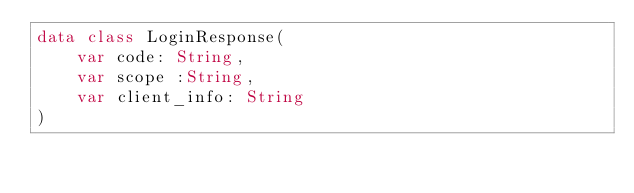<code> <loc_0><loc_0><loc_500><loc_500><_Kotlin_>data class LoginResponse(
    var code: String,
    var scope :String,
    var client_info: String
)</code> 